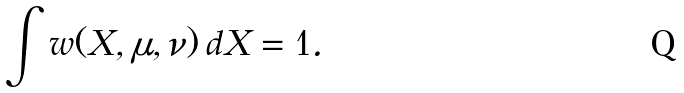Convert formula to latex. <formula><loc_0><loc_0><loc_500><loc_500>\int w ( { X } , { \mu } , { \nu } ) \, d { X } = 1 .</formula> 